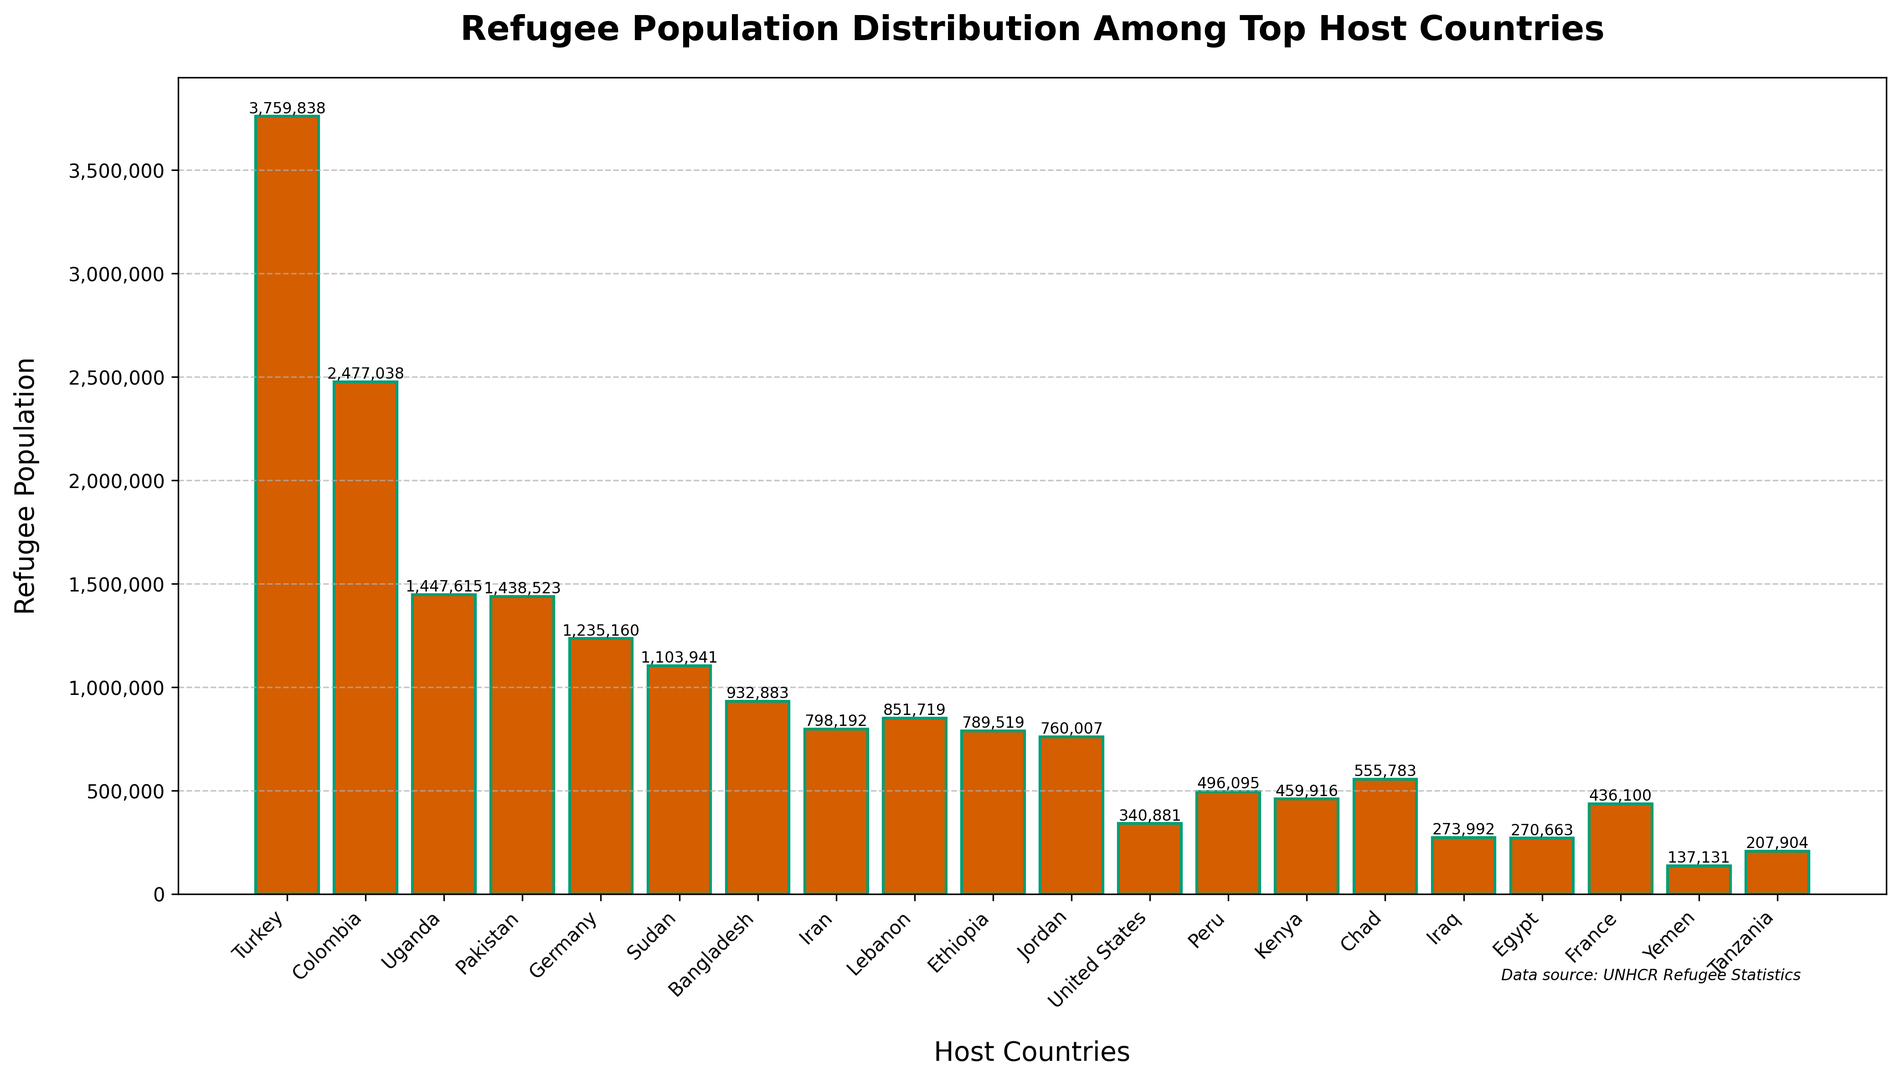Which country has the highest refugee population? By examining the bar heights on the chart, the tallest bar represents the country with the highest refugee population. Turkey has the highest refugee population according to the chart.
Answer: Turkey What is the total refugee population in Germany and Lebanon combined? Identify the refugee populations for Germany (1,235,160) and Lebanon (851,719), then sum these values: 1,235,160 + 851,719 = 2,086,879.
Answer: 2,086,879 How many more refugees does Turkey host compared to the United States? Identify the refugee populations for Turkey (3,759,838) and the United States (340,881), then subtract the U.S. population from Turkey's: 3,759,838 - 340,881 = 3,418,957.
Answer: 3,418,957 Which country has a refugee population closest to 1 million? Look for the bars around the 1 million mark on the y-axis. The country closest to this value is Sudan, with 1,103,941 refugees.
Answer: Sudan What is the average refugee population of the top three host countries? Identify the populations of the top three countries (Turkey: 3,759,838, Colombia: 2,477,038, Uganda: 1,447,615), then calculate the average: (3,759,838 + 2,477,038 + 1,447,615) / 3 ≈ 2,561,497.
Answer: 2,561,497 Which countries have a refugee population less than 500,000? Identify the bars whose heights represent populations below 500,000. These countries are Peru (496,095), Kenya (459,916), Yemen (137,131), Tanzania (207,904), and Iraq (273,992).
Answer: Peru, Kenya, Yemen, Tanzania, Iraq By how much does Colombia's refugee population exceed Iran's? Identify the refugee populations for Colombia (2,477,038) and Iran (798,192), then subtract Iran's population from Colombia's: 2,477,038 - 798,192 = 1,678,846.
Answer: 1,678,846 What is the median refugee population of the provided countries? First, list the refugee populations: 137,131, 207,904, 270,663, 273,992, 340,881, 436,100, 459,916, 496,095, 555,783, 760,007, 789,519, 798,192, 851,719, 932,883, 1,103,941, 1,235,160, 1,438,523, 1,447,615, 2,477,038, 3,759,838. The middle value (10th and 11th) is the average of 760,007 and 789,519, which is (760,007 + 789,519) / 2 = 774,763.
Answer: 774,763 How many total refugees are hosted by countries hosting more than 1 million refugees each? Identify the populations of the countries hosting more than 1 million refugees: Turkey (3,759,838), Colombia (2,477,038), Uganda (1,447,615), Pakistan (1,438,523), Germany (1,235,160), Sudan (1,103,941). Sum these values: 3,759,838 + 2,477,038 + 1,447,615 + 1,438,523 + 1,235,160 + 1,103,941 = 11,462,115.
Answer: 11,462,115 What is the difference between the refugee populations of Ethiopia and Egypt? Identify the refugee populations for Ethiopia (789,519) and Egypt (270,663), then subtract Egypt's population from Ethiopia's: 789,519 - 270,663 = 518,856.
Answer: 518,856 